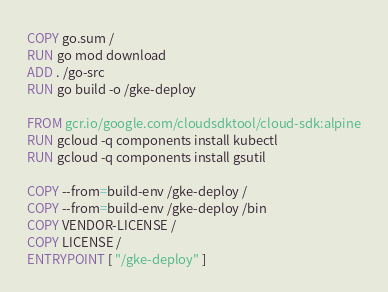Convert code to text. <code><loc_0><loc_0><loc_500><loc_500><_Dockerfile_>COPY go.sum /
RUN go mod download
ADD . /go-src
RUN go build -o /gke-deploy

FROM gcr.io/google.com/cloudsdktool/cloud-sdk:alpine
RUN gcloud -q components install kubectl
RUN gcloud -q components install gsutil

COPY --from=build-env /gke-deploy /
COPY --from=build-env /gke-deploy /bin
COPY VENDOR-LICENSE /
COPY LICENSE /
ENTRYPOINT [ "/gke-deploy" ]
</code> 